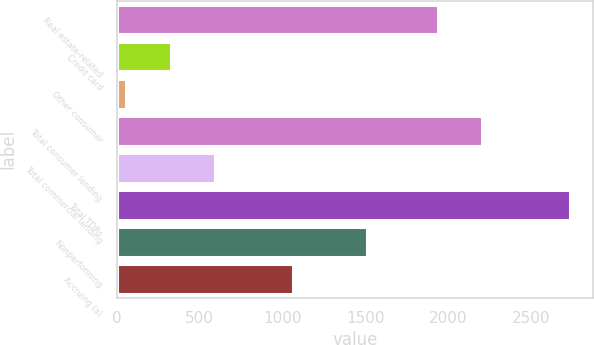<chart> <loc_0><loc_0><loc_500><loc_500><bar_chart><fcel>Real estate-related<fcel>Credit card<fcel>Other consumer<fcel>Total consumer lending<fcel>Total commercial lending<fcel>Total TDRs<fcel>Nonperforming<fcel>Accruing (a)<nl><fcel>1939<fcel>324.3<fcel>56<fcel>2207.3<fcel>592.6<fcel>2739<fcel>1511<fcel>1062<nl></chart> 